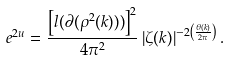<formula> <loc_0><loc_0><loc_500><loc_500>e ^ { 2 u } = \frac { \left [ l ( \partial ( \rho ^ { 2 } ( k ) ) ) \right ] ^ { 2 } } { 4 \pi ^ { 2 } } \left | \zeta ( k ) \right | ^ { - 2 \left ( \frac { \theta ( k ) } { 2 \pi } \right ) } .</formula> 